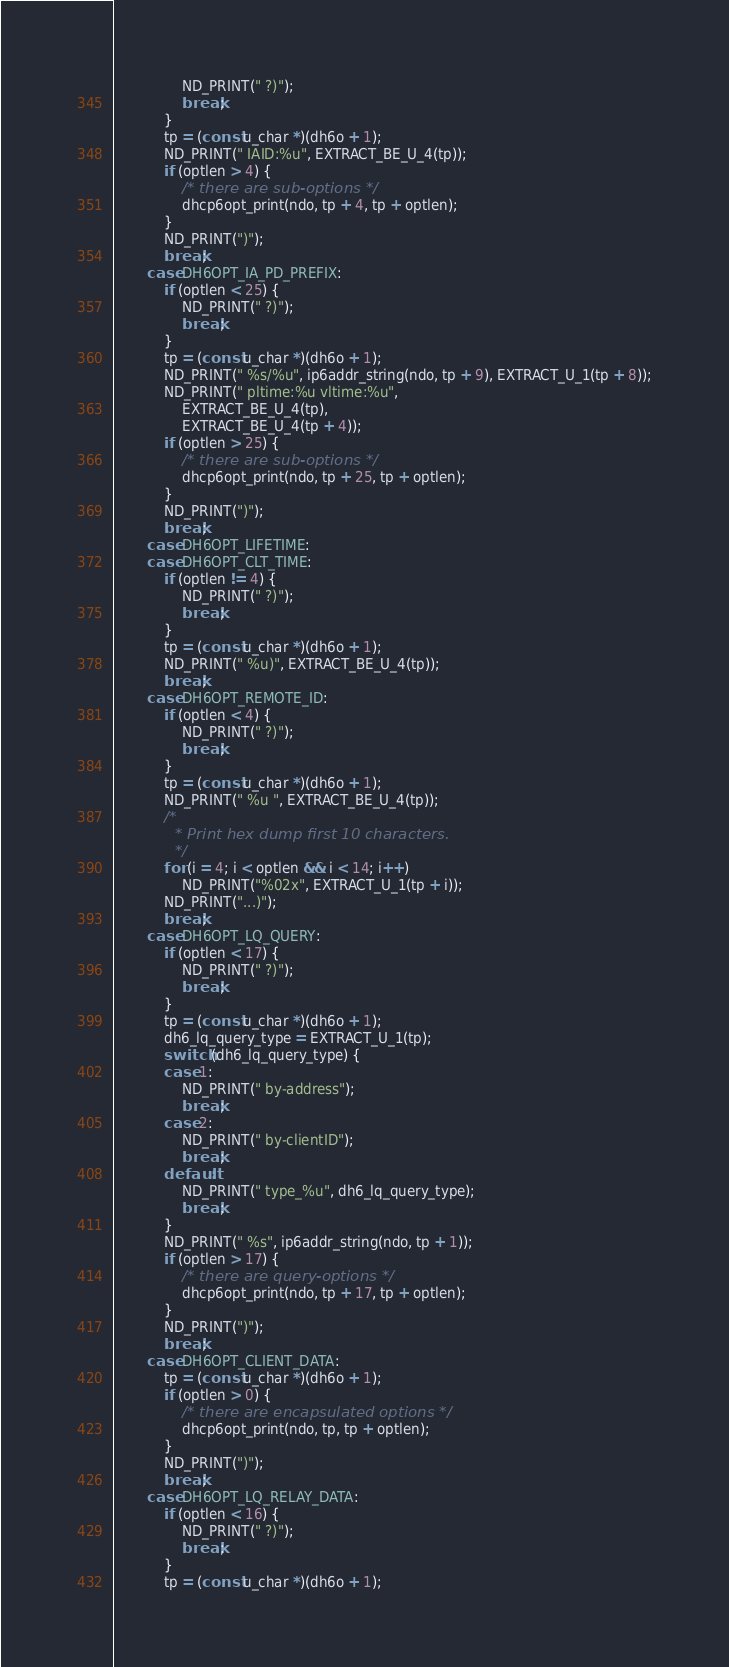Convert code to text. <code><loc_0><loc_0><loc_500><loc_500><_C_>				ND_PRINT(" ?)");
				break;
			}
			tp = (const u_char *)(dh6o + 1);
			ND_PRINT(" IAID:%u", EXTRACT_BE_U_4(tp));
			if (optlen > 4) {
				/* there are sub-options */
				dhcp6opt_print(ndo, tp + 4, tp + optlen);
			}
			ND_PRINT(")");
			break;
		case DH6OPT_IA_PD_PREFIX:
			if (optlen < 25) {
				ND_PRINT(" ?)");
				break;
			}
			tp = (const u_char *)(dh6o + 1);
			ND_PRINT(" %s/%u", ip6addr_string(ndo, tp + 9), EXTRACT_U_1(tp + 8));
			ND_PRINT(" pltime:%u vltime:%u",
			    EXTRACT_BE_U_4(tp),
			    EXTRACT_BE_U_4(tp + 4));
			if (optlen > 25) {
				/* there are sub-options */
				dhcp6opt_print(ndo, tp + 25, tp + optlen);
			}
			ND_PRINT(")");
			break;
		case DH6OPT_LIFETIME:
		case DH6OPT_CLT_TIME:
			if (optlen != 4) {
				ND_PRINT(" ?)");
				break;
			}
			tp = (const u_char *)(dh6o + 1);
			ND_PRINT(" %u)", EXTRACT_BE_U_4(tp));
			break;
		case DH6OPT_REMOTE_ID:
			if (optlen < 4) {
				ND_PRINT(" ?)");
				break;
			}
			tp = (const u_char *)(dh6o + 1);
			ND_PRINT(" %u ", EXTRACT_BE_U_4(tp));
			/*
			 * Print hex dump first 10 characters.
			 */
			for (i = 4; i < optlen && i < 14; i++)
				ND_PRINT("%02x", EXTRACT_U_1(tp + i));
			ND_PRINT("...)");
			break;
		case DH6OPT_LQ_QUERY:
			if (optlen < 17) {
				ND_PRINT(" ?)");
				break;
			}
			tp = (const u_char *)(dh6o + 1);
			dh6_lq_query_type = EXTRACT_U_1(tp);
			switch (dh6_lq_query_type) {
			case 1:
				ND_PRINT(" by-address");
				break;
			case 2:
				ND_PRINT(" by-clientID");
				break;
			default:
				ND_PRINT(" type_%u", dh6_lq_query_type);
				break;
			}
			ND_PRINT(" %s", ip6addr_string(ndo, tp + 1));
			if (optlen > 17) {
				/* there are query-options */
				dhcp6opt_print(ndo, tp + 17, tp + optlen);
			}
			ND_PRINT(")");
			break;
		case DH6OPT_CLIENT_DATA:
			tp = (const u_char *)(dh6o + 1);
			if (optlen > 0) {
				/* there are encapsulated options */
				dhcp6opt_print(ndo, tp, tp + optlen);
			}
			ND_PRINT(")");
			break;
		case DH6OPT_LQ_RELAY_DATA:
			if (optlen < 16) {
				ND_PRINT(" ?)");
				break;
			}
			tp = (const u_char *)(dh6o + 1);</code> 